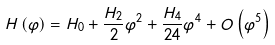Convert formula to latex. <formula><loc_0><loc_0><loc_500><loc_500>H \left ( \varphi \right ) = H _ { 0 } + \frac { H _ { 2 } } 2 \varphi ^ { 2 } + \frac { H _ { 4 } } { 2 4 } \varphi ^ { 4 } + O \left ( \varphi ^ { 5 } \right )</formula> 